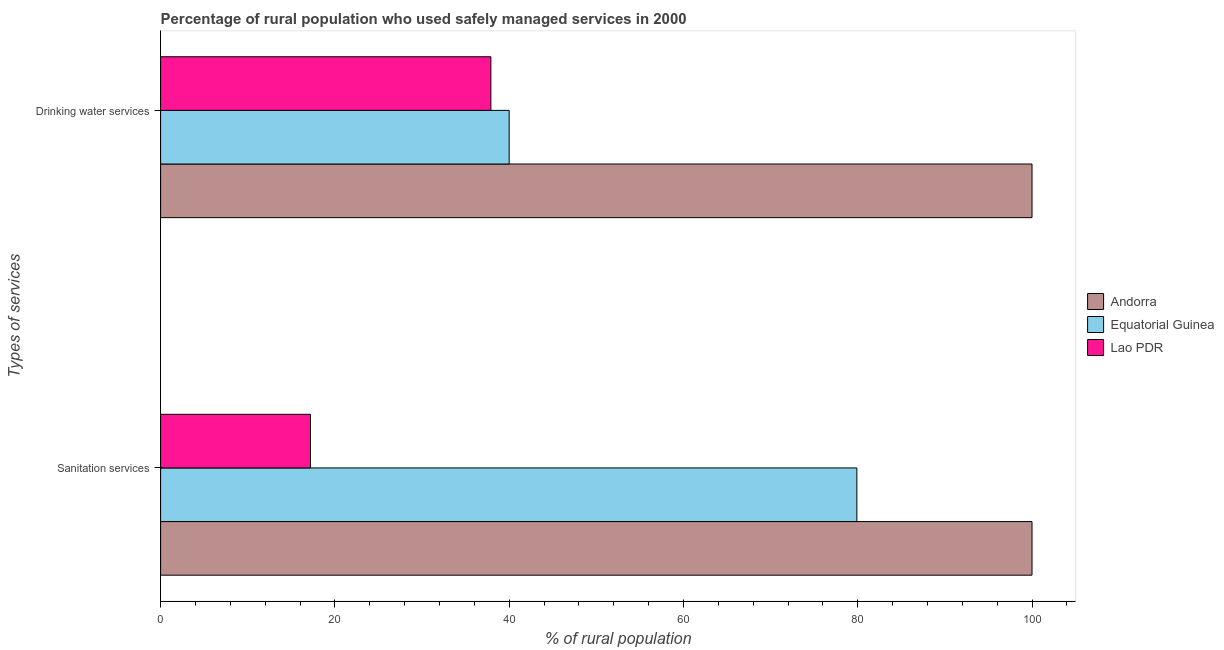How many different coloured bars are there?
Ensure brevity in your answer.  3. How many groups of bars are there?
Offer a terse response. 2. Are the number of bars per tick equal to the number of legend labels?
Give a very brief answer. Yes. What is the label of the 2nd group of bars from the top?
Your answer should be compact. Sanitation services. What is the percentage of rural population who used sanitation services in Lao PDR?
Provide a short and direct response. 17.2. Across all countries, what is the minimum percentage of rural population who used sanitation services?
Your response must be concise. 17.2. In which country was the percentage of rural population who used sanitation services maximum?
Offer a very short reply. Andorra. In which country was the percentage of rural population who used drinking water services minimum?
Give a very brief answer. Lao PDR. What is the total percentage of rural population who used drinking water services in the graph?
Your answer should be compact. 177.9. What is the difference between the percentage of rural population who used sanitation services in Andorra and that in Lao PDR?
Offer a terse response. 82.8. What is the difference between the percentage of rural population who used drinking water services in Andorra and the percentage of rural population who used sanitation services in Equatorial Guinea?
Ensure brevity in your answer.  20.1. What is the average percentage of rural population who used sanitation services per country?
Your response must be concise. 65.7. What is the difference between the percentage of rural population who used drinking water services and percentage of rural population who used sanitation services in Equatorial Guinea?
Your answer should be compact. -39.9. In how many countries, is the percentage of rural population who used drinking water services greater than 88 %?
Give a very brief answer. 1. What is the ratio of the percentage of rural population who used sanitation services in Andorra to that in Lao PDR?
Provide a succinct answer. 5.81. What does the 2nd bar from the top in Sanitation services represents?
Your answer should be very brief. Equatorial Guinea. What does the 1st bar from the bottom in Sanitation services represents?
Your response must be concise. Andorra. What is the difference between two consecutive major ticks on the X-axis?
Provide a short and direct response. 20. Are the values on the major ticks of X-axis written in scientific E-notation?
Keep it short and to the point. No. Does the graph contain grids?
Make the answer very short. No. How are the legend labels stacked?
Your answer should be very brief. Vertical. What is the title of the graph?
Provide a short and direct response. Percentage of rural population who used safely managed services in 2000. What is the label or title of the X-axis?
Your answer should be compact. % of rural population. What is the label or title of the Y-axis?
Provide a short and direct response. Types of services. What is the % of rural population of Andorra in Sanitation services?
Provide a succinct answer. 100. What is the % of rural population in Equatorial Guinea in Sanitation services?
Your answer should be compact. 79.9. What is the % of rural population in Lao PDR in Sanitation services?
Your response must be concise. 17.2. What is the % of rural population in Lao PDR in Drinking water services?
Provide a succinct answer. 37.9. Across all Types of services, what is the maximum % of rural population in Andorra?
Ensure brevity in your answer.  100. Across all Types of services, what is the maximum % of rural population in Equatorial Guinea?
Your answer should be very brief. 79.9. Across all Types of services, what is the maximum % of rural population in Lao PDR?
Give a very brief answer. 37.9. What is the total % of rural population in Andorra in the graph?
Offer a very short reply. 200. What is the total % of rural population in Equatorial Guinea in the graph?
Provide a succinct answer. 119.9. What is the total % of rural population of Lao PDR in the graph?
Your answer should be very brief. 55.1. What is the difference between the % of rural population in Equatorial Guinea in Sanitation services and that in Drinking water services?
Make the answer very short. 39.9. What is the difference between the % of rural population of Lao PDR in Sanitation services and that in Drinking water services?
Keep it short and to the point. -20.7. What is the difference between the % of rural population in Andorra in Sanitation services and the % of rural population in Equatorial Guinea in Drinking water services?
Offer a terse response. 60. What is the difference between the % of rural population of Andorra in Sanitation services and the % of rural population of Lao PDR in Drinking water services?
Provide a succinct answer. 62.1. What is the difference between the % of rural population in Equatorial Guinea in Sanitation services and the % of rural population in Lao PDR in Drinking water services?
Offer a very short reply. 42. What is the average % of rural population in Andorra per Types of services?
Make the answer very short. 100. What is the average % of rural population of Equatorial Guinea per Types of services?
Your answer should be compact. 59.95. What is the average % of rural population of Lao PDR per Types of services?
Your response must be concise. 27.55. What is the difference between the % of rural population of Andorra and % of rural population of Equatorial Guinea in Sanitation services?
Your response must be concise. 20.1. What is the difference between the % of rural population of Andorra and % of rural population of Lao PDR in Sanitation services?
Provide a short and direct response. 82.8. What is the difference between the % of rural population of Equatorial Guinea and % of rural population of Lao PDR in Sanitation services?
Your answer should be compact. 62.7. What is the difference between the % of rural population in Andorra and % of rural population in Lao PDR in Drinking water services?
Give a very brief answer. 62.1. What is the difference between the % of rural population in Equatorial Guinea and % of rural population in Lao PDR in Drinking water services?
Your answer should be very brief. 2.1. What is the ratio of the % of rural population in Andorra in Sanitation services to that in Drinking water services?
Your answer should be compact. 1. What is the ratio of the % of rural population of Equatorial Guinea in Sanitation services to that in Drinking water services?
Provide a succinct answer. 2. What is the ratio of the % of rural population in Lao PDR in Sanitation services to that in Drinking water services?
Your answer should be very brief. 0.45. What is the difference between the highest and the second highest % of rural population in Andorra?
Ensure brevity in your answer.  0. What is the difference between the highest and the second highest % of rural population of Equatorial Guinea?
Your answer should be compact. 39.9. What is the difference between the highest and the second highest % of rural population of Lao PDR?
Offer a very short reply. 20.7. What is the difference between the highest and the lowest % of rural population of Andorra?
Ensure brevity in your answer.  0. What is the difference between the highest and the lowest % of rural population in Equatorial Guinea?
Make the answer very short. 39.9. What is the difference between the highest and the lowest % of rural population in Lao PDR?
Your response must be concise. 20.7. 